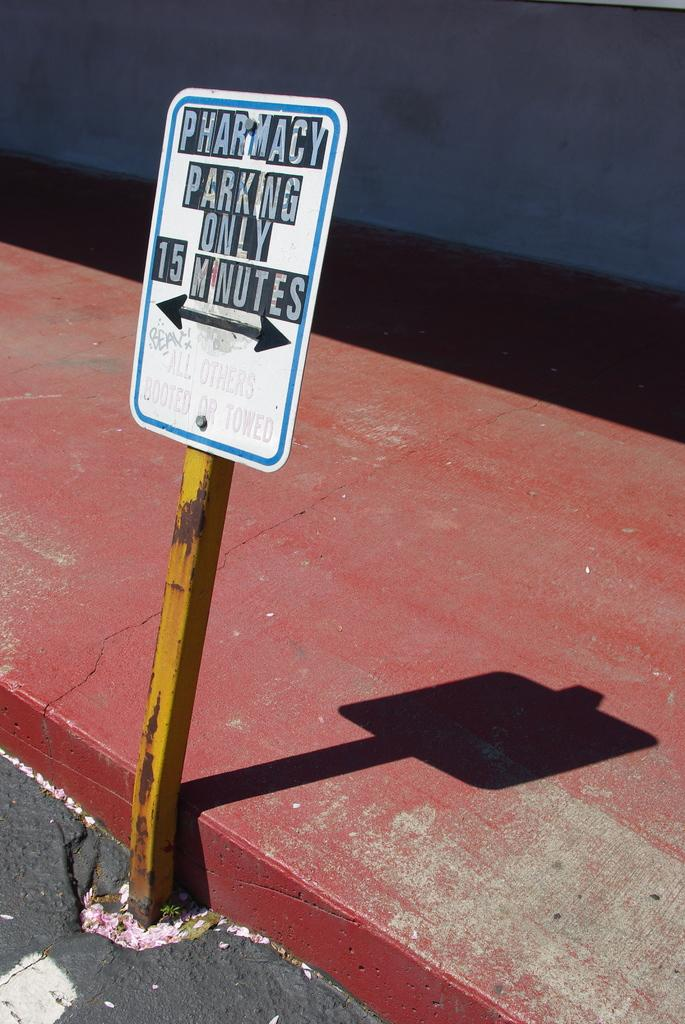<image>
Summarize the visual content of the image. A sign designates the parking spaces for the pharmacy. 